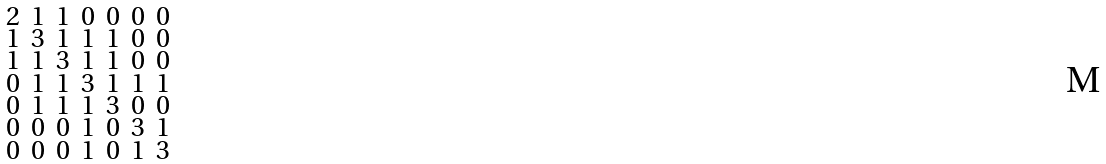Convert formula to latex. <formula><loc_0><loc_0><loc_500><loc_500>\begin{smallmatrix} 2 & 1 & 1 & 0 & 0 & 0 & 0 \\ 1 & 3 & 1 & 1 & 1 & 0 & 0 \\ 1 & 1 & 3 & 1 & 1 & 0 & 0 \\ 0 & 1 & 1 & 3 & 1 & 1 & 1 \\ 0 & 1 & 1 & 1 & 3 & 0 & 0 \\ 0 & 0 & 0 & 1 & 0 & 3 & 1 \\ 0 & 0 & 0 & 1 & 0 & 1 & 3 \end{smallmatrix}</formula> 